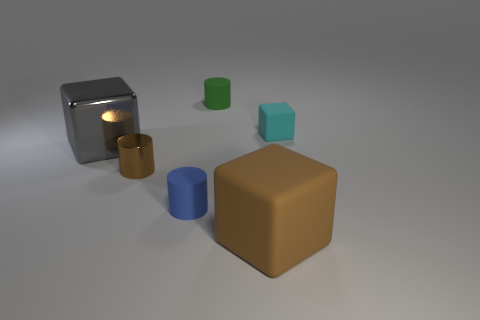Does the large block in front of the small blue cylinder have the same material as the green thing?
Your answer should be compact. Yes. Are there an equal number of cyan matte blocks that are on the left side of the brown matte object and blue objects?
Ensure brevity in your answer.  No. How big is the blue matte thing?
Make the answer very short. Small. What is the material of the object that is the same color as the metallic cylinder?
Your answer should be very brief. Rubber. How many big metallic objects have the same color as the metallic block?
Offer a very short reply. 0. Does the cyan rubber thing have the same size as the blue object?
Your answer should be compact. Yes. What is the size of the brown thing that is in front of the small thing in front of the small shiny object?
Make the answer very short. Large. Do the small rubber cube and the tiny cylinder behind the cyan matte object have the same color?
Your answer should be compact. No. Are there any gray spheres that have the same size as the brown metal cylinder?
Ensure brevity in your answer.  No. What size is the matte object behind the cyan block?
Your answer should be compact. Small. 